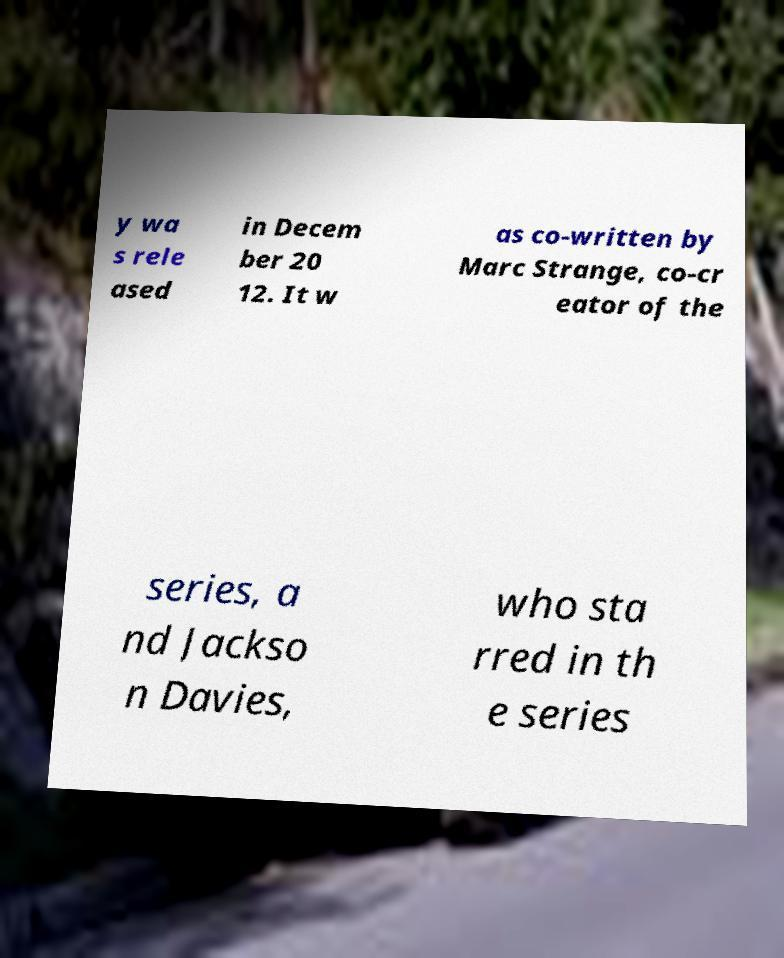Can you accurately transcribe the text from the provided image for me? y wa s rele ased in Decem ber 20 12. It w as co-written by Marc Strange, co-cr eator of the series, a nd Jackso n Davies, who sta rred in th e series 